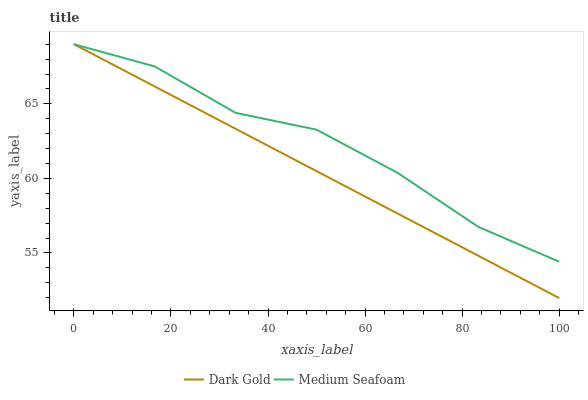Does Dark Gold have the minimum area under the curve?
Answer yes or no. Yes. Does Medium Seafoam have the maximum area under the curve?
Answer yes or no. Yes. Does Dark Gold have the maximum area under the curve?
Answer yes or no. No. Is Dark Gold the smoothest?
Answer yes or no. Yes. Is Medium Seafoam the roughest?
Answer yes or no. Yes. Is Dark Gold the roughest?
Answer yes or no. No. Does Dark Gold have the lowest value?
Answer yes or no. Yes. Does Dark Gold have the highest value?
Answer yes or no. Yes. Does Medium Seafoam intersect Dark Gold?
Answer yes or no. Yes. Is Medium Seafoam less than Dark Gold?
Answer yes or no. No. Is Medium Seafoam greater than Dark Gold?
Answer yes or no. No. 